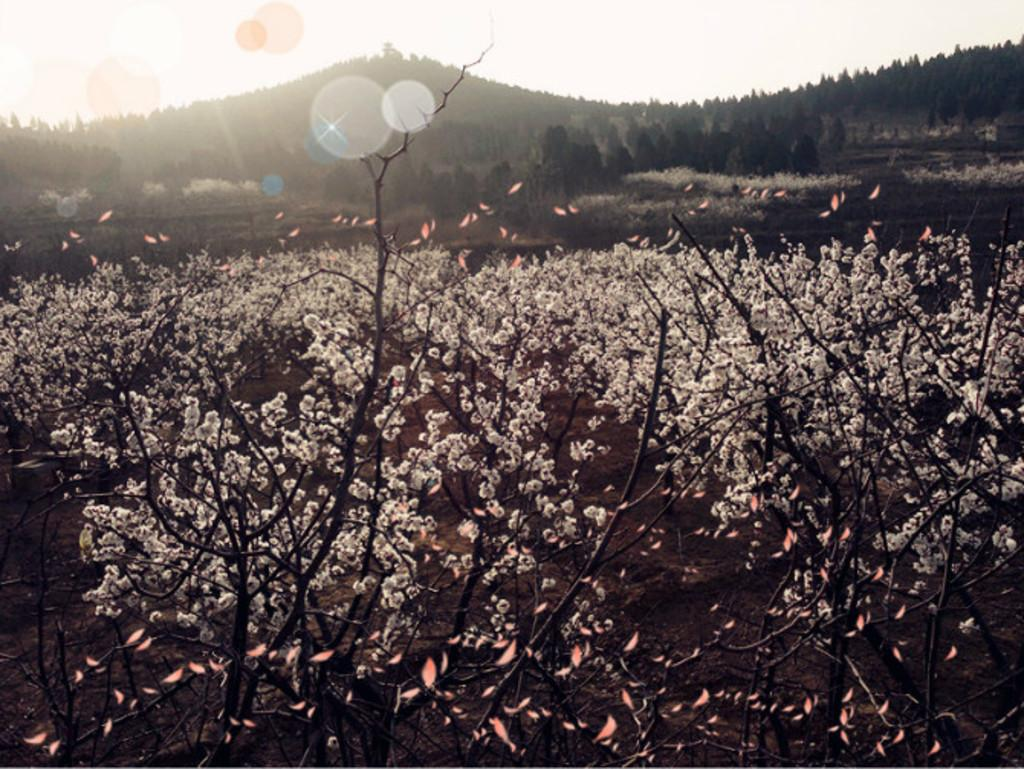What is located in the foreground of the image? There are plants in the foreground of the image. What can be seen in the background of the image? There are trees and mountains in the background of the image. What is visible at the top of the image? The sky is visible at the top of the image. How much money is being exchanged between the plants in the image? There is no money present in the image, as it features plants in the foreground and trees, mountains, and the sky in the background. What type of coat is being worn by the trees in the background? There are no coats present in the image, as it features trees in the background without any clothing or accessories. 